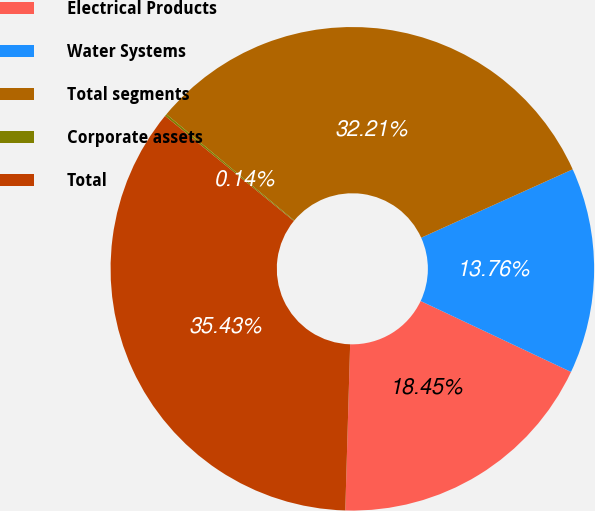Convert chart. <chart><loc_0><loc_0><loc_500><loc_500><pie_chart><fcel>Electrical Products<fcel>Water Systems<fcel>Total segments<fcel>Corporate assets<fcel>Total<nl><fcel>18.45%<fcel>13.76%<fcel>32.21%<fcel>0.14%<fcel>35.43%<nl></chart> 